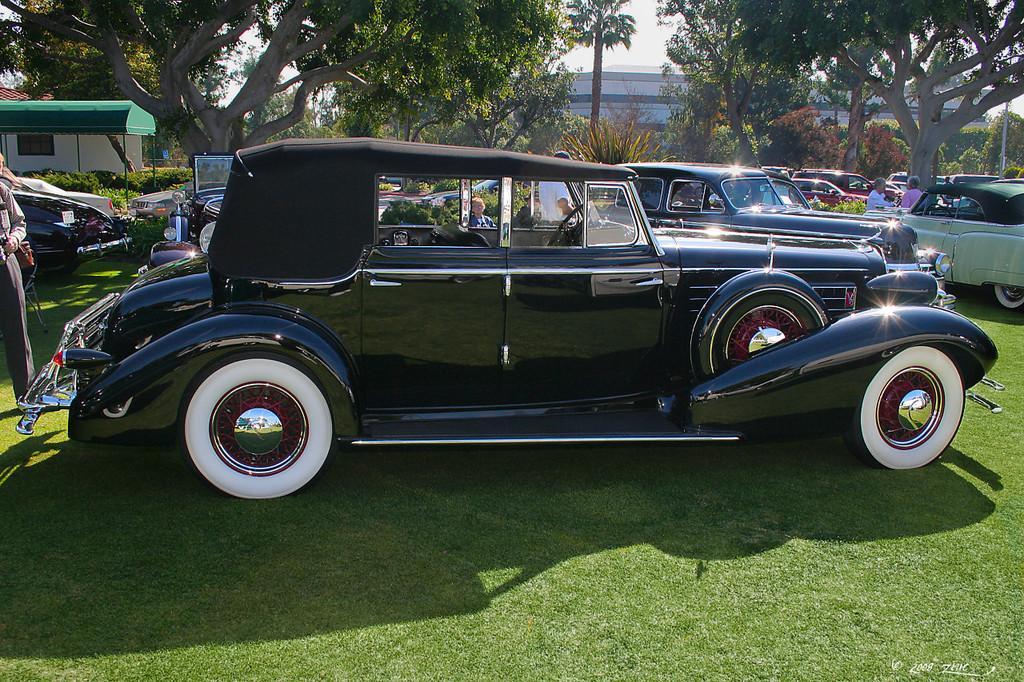Please provide a concise description of this image. In this image in the center there are some cars and some persons are standing, and at the bottom there is grass. In the background there are some houses, trees and poles and at the top of the image there is sky. 